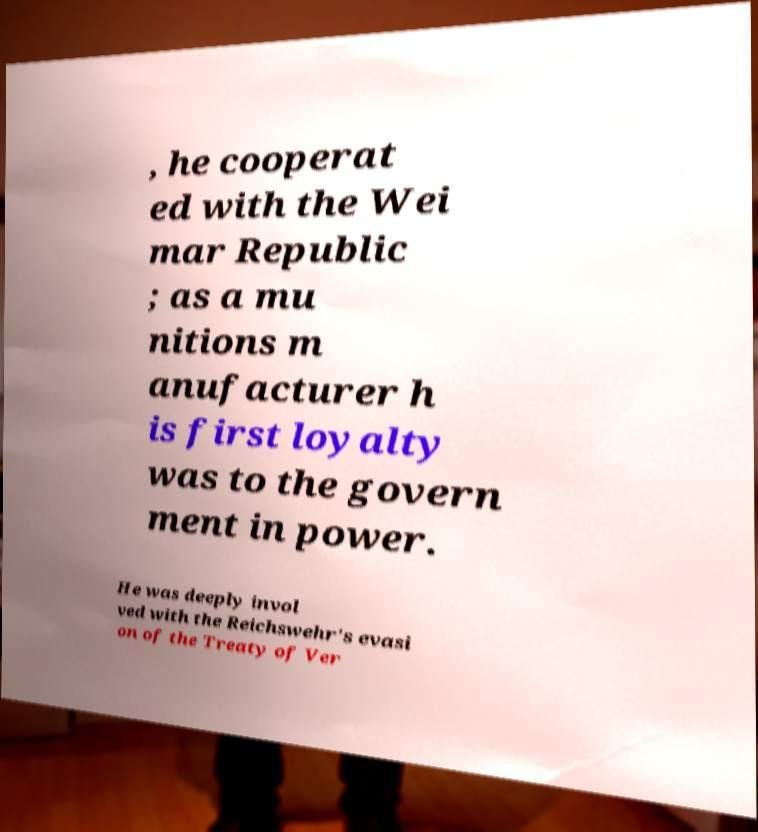For documentation purposes, I need the text within this image transcribed. Could you provide that? , he cooperat ed with the Wei mar Republic ; as a mu nitions m anufacturer h is first loyalty was to the govern ment in power. He was deeply invol ved with the Reichswehr's evasi on of the Treaty of Ver 